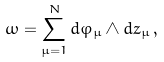<formula> <loc_0><loc_0><loc_500><loc_500>\omega = \sum _ { \mu = 1 } ^ { N } d \varphi _ { \mu } \wedge d z _ { \mu } \, ,</formula> 